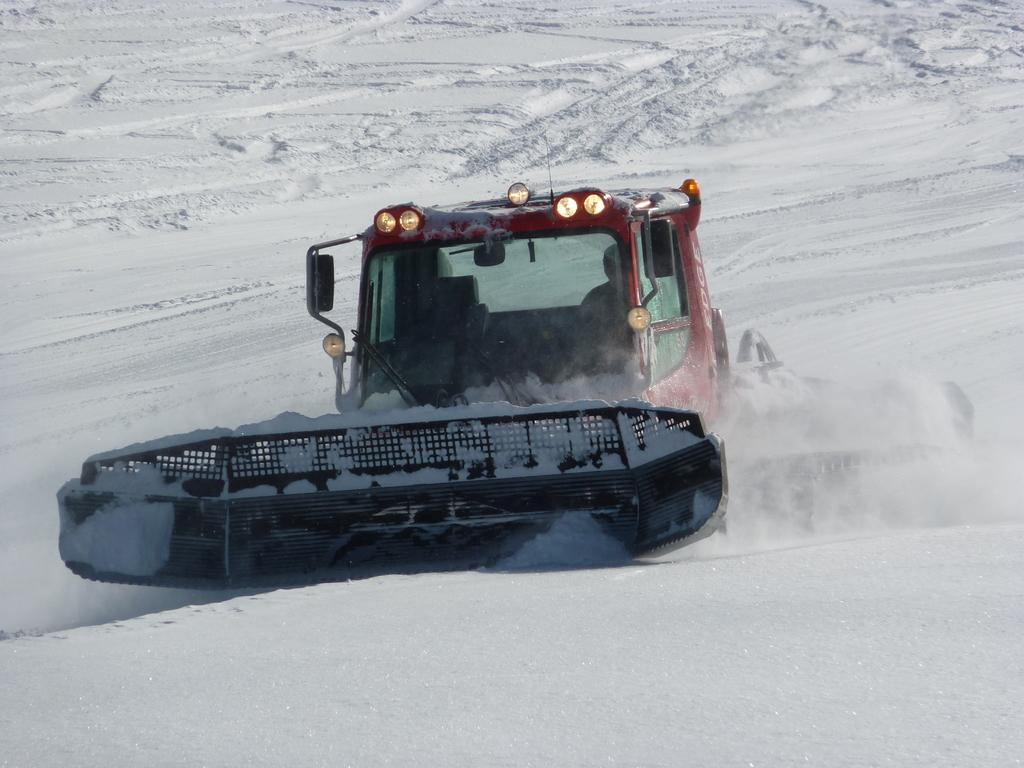What is the main subject of the image? There is a person in the image. Where is the person located? The person is sitting inside a vehicle. What is the setting of the image? The vehicle is placed on the snow. How many geese are visible on the vehicle in the image? There are no geese present in the image; the vehicle is placed on the snow. 